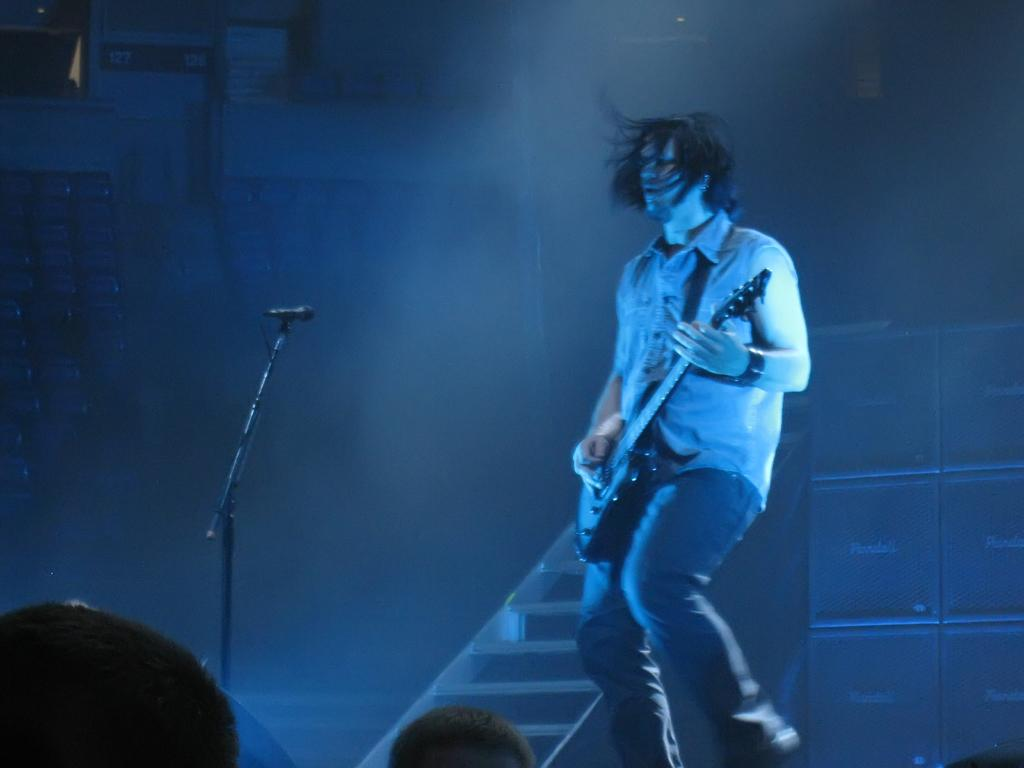What is the main subject of the image? There is a man in the image. What is the man doing in the image? The man is walking in the image. What object is the man holding in his hand? The man is holding a guitar in his hand. What is the purpose of the microphone in the image? The microphone is on a stand, which suggests it is being used for amplifying sound. What can be seen in the background of the image? There are boxes and a staircase in the background of the image. What type of card is the man holding in the image? There is no card present in the image; the man is holding a guitar. What scene is depicted on the boxes in the background of the image? There is no scene depicted on the boxes in the image; they are just plain boxes. 